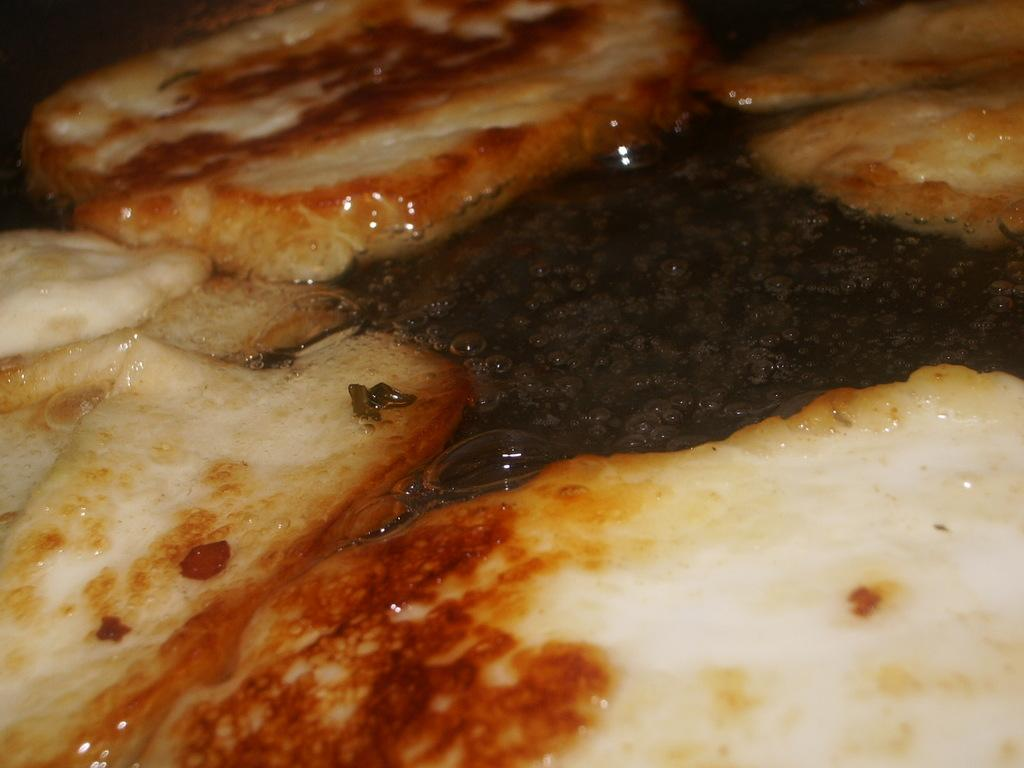What type of food item is present in the image? There is a food item in the image, but its specific type cannot be determined from the provided facts. Can you describe the color of the food item? The food item is brown and white in color. Is there any liquid associated with the food item? Yes, there is some liquid associated with the food item. What type of son can be heard singing in the image? There is no son or any audible element present in the image, as it is a static visual representation. How many boats are visible in the image? There are no boats present in the image. 